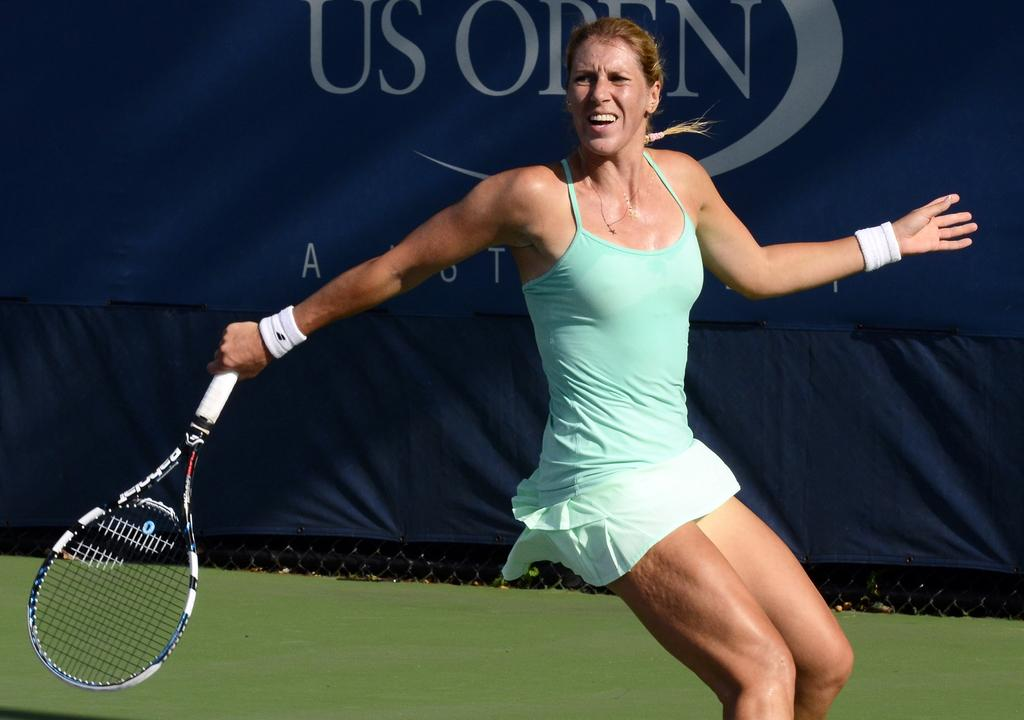Who is the main subject in the image? There is a woman in the image. What is the woman doing in the image? The woman is playing badminton. What object is the woman holding in the image? The woman is holding a bat. Where is the game taking place? The game is taking place in a court. What can be seen in the background of the image? There is a blue colored curtain in the background. Can you tell me how many bananas are on the court in the image? There are no bananas present in the image; the woman is playing badminton with a bat. What type of bottle is visible on the court in the image? There is no bottle visible on the court in the image. 